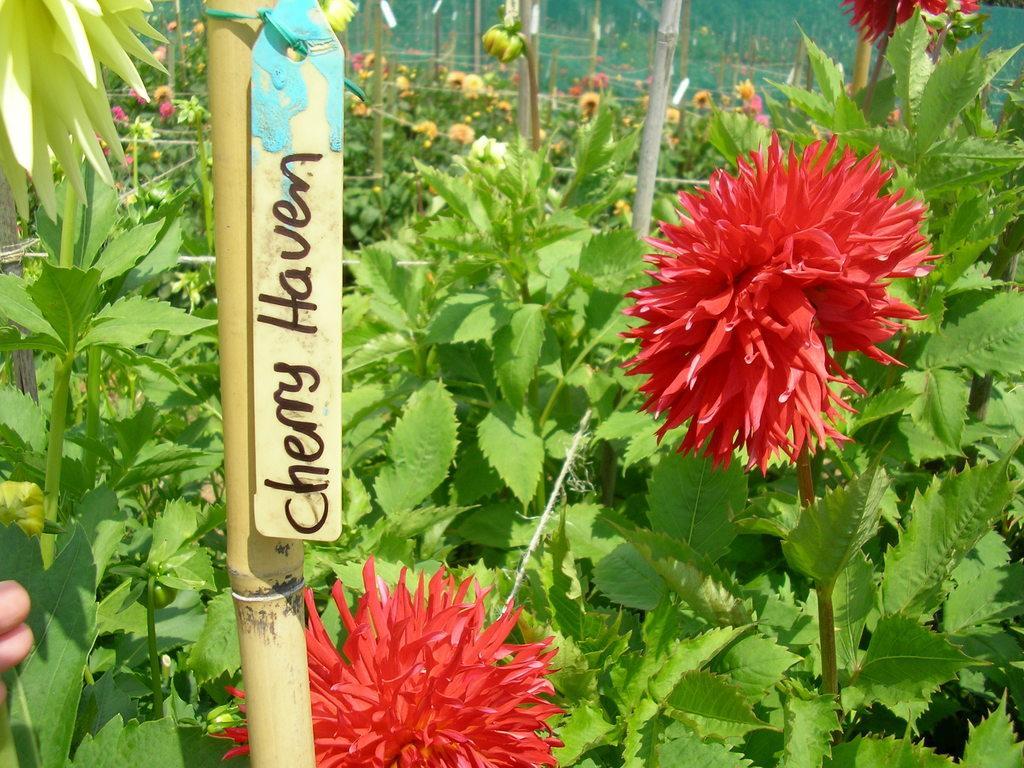Could you give a brief overview of what you see in this image? In this picture I can see plants with flowers and I can see few sticks and a small board to a stick with some text. I can see a human hand on the left side of the picture. 